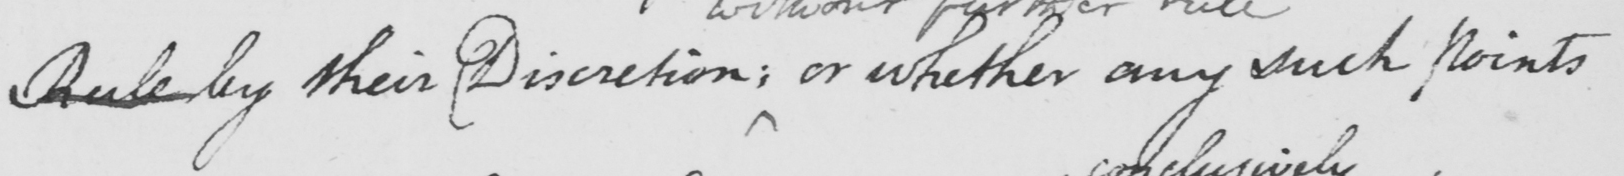What does this handwritten line say? Rule by their Discretion ; or whether any such points 